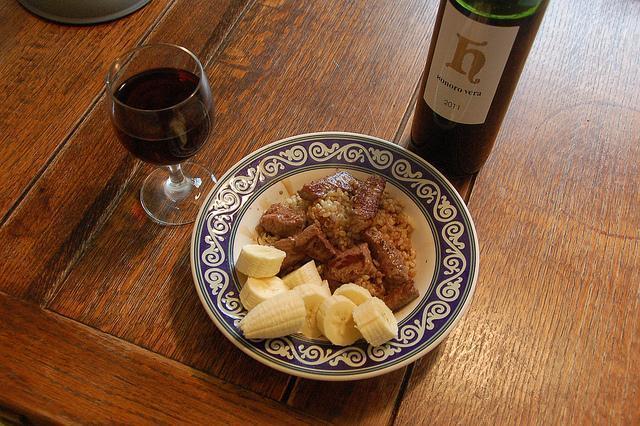How many men are wearing uniforms?
Give a very brief answer. 0. 